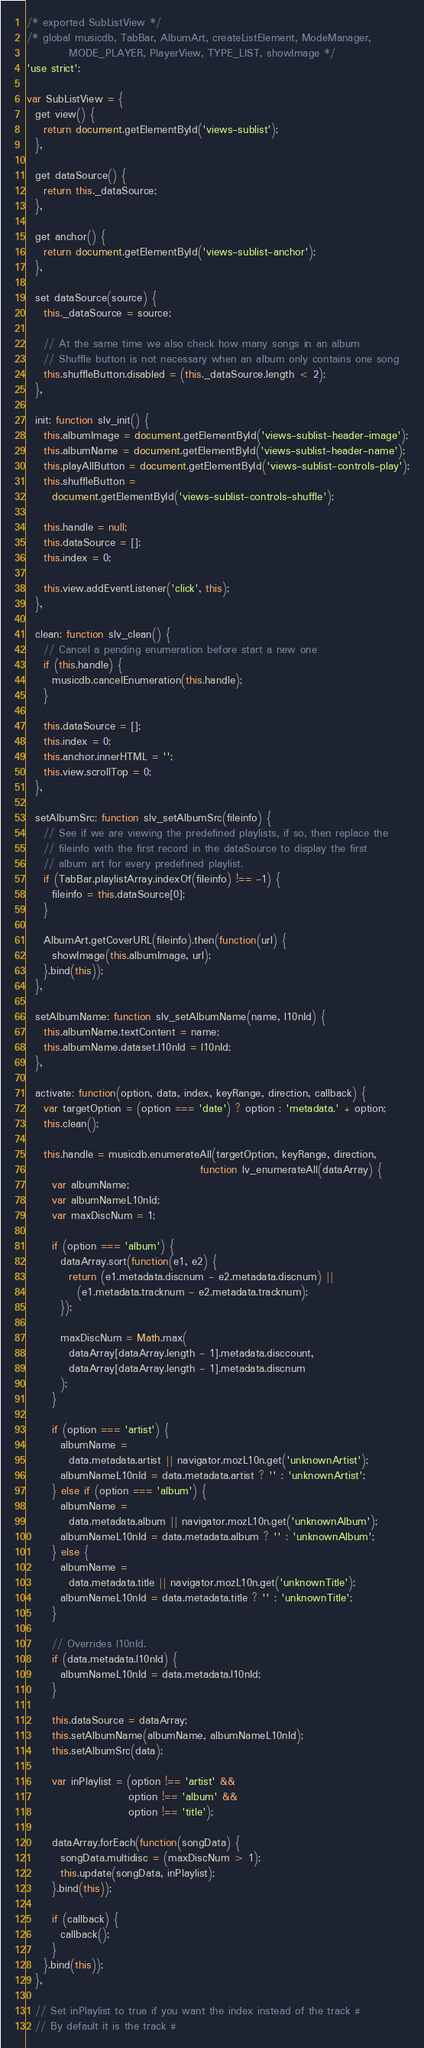Convert code to text. <code><loc_0><loc_0><loc_500><loc_500><_JavaScript_>/* exported SubListView */
/* global musicdb, TabBar, AlbumArt, createListElement, ModeManager,
          MODE_PLAYER, PlayerView, TYPE_LIST, showImage */
'use strict';

var SubListView = {
  get view() {
    return document.getElementById('views-sublist');
  },

  get dataSource() {
    return this._dataSource;
  },

  get anchor() {
    return document.getElementById('views-sublist-anchor');
  },

  set dataSource(source) {
    this._dataSource = source;

    // At the same time we also check how many songs in an album
    // Shuffle button is not necessary when an album only contains one song
    this.shuffleButton.disabled = (this._dataSource.length < 2);
  },

  init: function slv_init() {
    this.albumImage = document.getElementById('views-sublist-header-image');
    this.albumName = document.getElementById('views-sublist-header-name');
    this.playAllButton = document.getElementById('views-sublist-controls-play');
    this.shuffleButton =
      document.getElementById('views-sublist-controls-shuffle');

    this.handle = null;
    this.dataSource = [];
    this.index = 0;

    this.view.addEventListener('click', this);
  },

  clean: function slv_clean() {
    // Cancel a pending enumeration before start a new one
    if (this.handle) {
      musicdb.cancelEnumeration(this.handle);
    }

    this.dataSource = [];
    this.index = 0;
    this.anchor.innerHTML = '';
    this.view.scrollTop = 0;
  },

  setAlbumSrc: function slv_setAlbumSrc(fileinfo) {
    // See if we are viewing the predefined playlists, if so, then replace the
    // fileinfo with the first record in the dataSource to display the first
    // album art for every predefined playlist.
    if (TabBar.playlistArray.indexOf(fileinfo) !== -1) {
      fileinfo = this.dataSource[0];
    }

    AlbumArt.getCoverURL(fileinfo).then(function(url) {
      showImage(this.albumImage, url);
    }.bind(this));
  },

  setAlbumName: function slv_setAlbumName(name, l10nId) {
    this.albumName.textContent = name;
    this.albumName.dataset.l10nId = l10nId;
  },

  activate: function(option, data, index, keyRange, direction, callback) {
    var targetOption = (option === 'date') ? option : 'metadata.' + option;
    this.clean();

    this.handle = musicdb.enumerateAll(targetOption, keyRange, direction,
                                         function lv_enumerateAll(dataArray) {
      var albumName;
      var albumNameL10nId;
      var maxDiscNum = 1;

      if (option === 'album') {
        dataArray.sort(function(e1, e2) {
          return (e1.metadata.discnum - e2.metadata.discnum) ||
            (e1.metadata.tracknum - e2.metadata.tracknum);
        });

        maxDiscNum = Math.max(
          dataArray[dataArray.length - 1].metadata.disccount,
          dataArray[dataArray.length - 1].metadata.discnum
        );
      }

      if (option === 'artist') {
        albumName =
          data.metadata.artist || navigator.mozL10n.get('unknownArtist');
        albumNameL10nId = data.metadata.artist ? '' : 'unknownArtist';
      } else if (option === 'album') {
        albumName =
          data.metadata.album || navigator.mozL10n.get('unknownAlbum');
        albumNameL10nId = data.metadata.album ? '' : 'unknownAlbum';
      } else {
        albumName =
          data.metadata.title || navigator.mozL10n.get('unknownTitle');
        albumNameL10nId = data.metadata.title ? '' : 'unknownTitle';
      }

      // Overrides l10nId.
      if (data.metadata.l10nId) {
        albumNameL10nId = data.metadata.l10nId;
      }

      this.dataSource = dataArray;
      this.setAlbumName(albumName, albumNameL10nId);
      this.setAlbumSrc(data);

      var inPlaylist = (option !== 'artist' &&
                        option !== 'album' &&
                        option !== 'title');

      dataArray.forEach(function(songData) {
        songData.multidisc = (maxDiscNum > 1);
        this.update(songData, inPlaylist);
      }.bind(this));

      if (callback) {
        callback();
      }
    }.bind(this));
  },

  // Set inPlaylist to true if you want the index instead of the track #
  // By default it is the track #</code> 